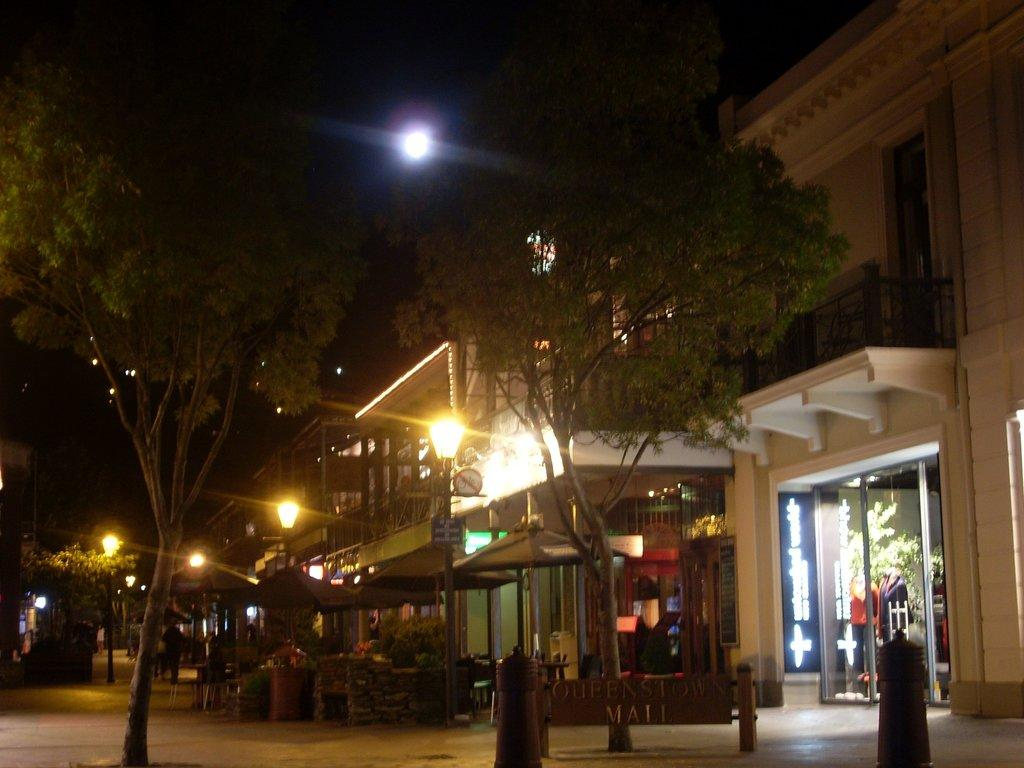What type of natural elements can be seen in the image? There are trees in the image. What man-made structures are present on the ground? There are street light poles on the ground. What can be seen in the distance in the image? There are buildings visible in the background. What is the condition of the sky in the image? The sky is clear in the image. Where are the dolls hanging from the yoke in the image? There are no dolls or yoke present in the image. What type of calendar is visible on the tree in the image? There is no calendar visible in the image; it features trees, street light poles, buildings, and a clear sky. 